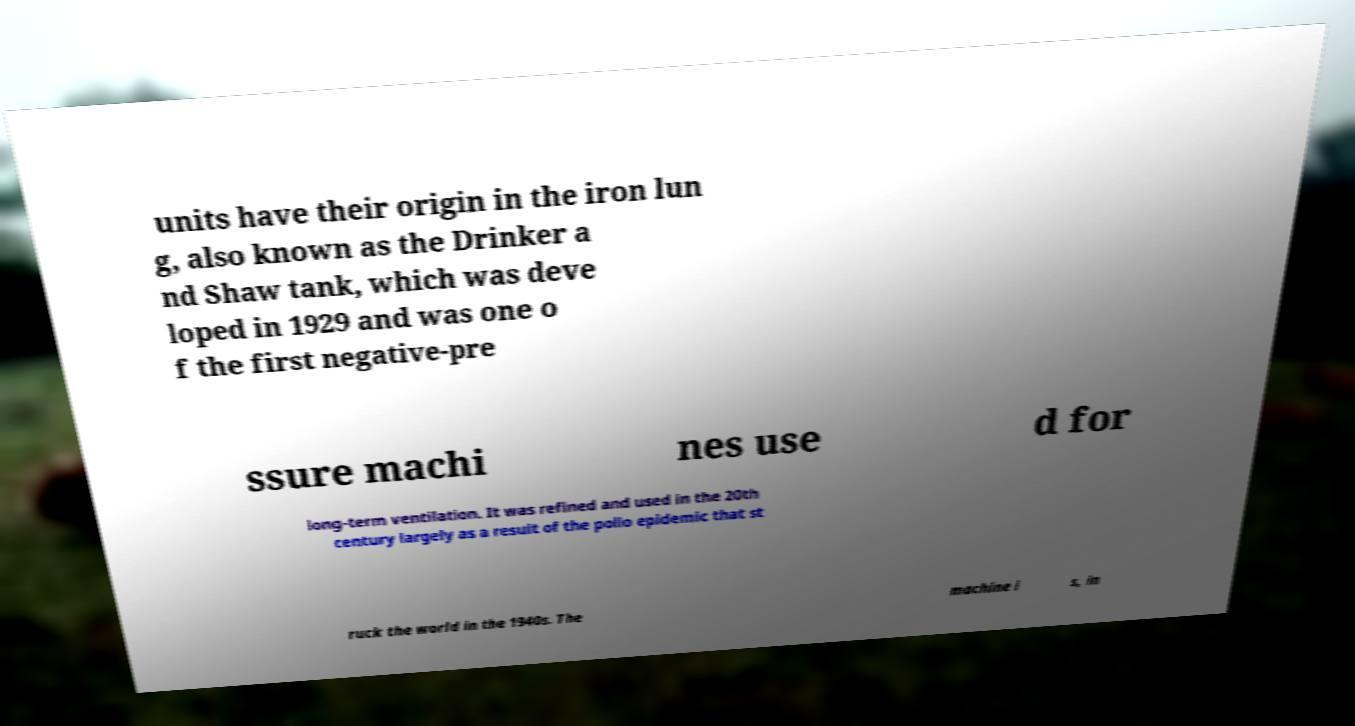There's text embedded in this image that I need extracted. Can you transcribe it verbatim? units have their origin in the iron lun g, also known as the Drinker a nd Shaw tank, which was deve loped in 1929 and was one o f the first negative-pre ssure machi nes use d for long-term ventilation. It was refined and used in the 20th century largely as a result of the polio epidemic that st ruck the world in the 1940s. The machine i s, in 